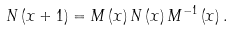Convert formula to latex. <formula><loc_0><loc_0><loc_500><loc_500>N \left ( x + 1 \right ) = M \left ( x \right ) N \left ( x \right ) M ^ { - 1 } \left ( x \right ) .</formula> 